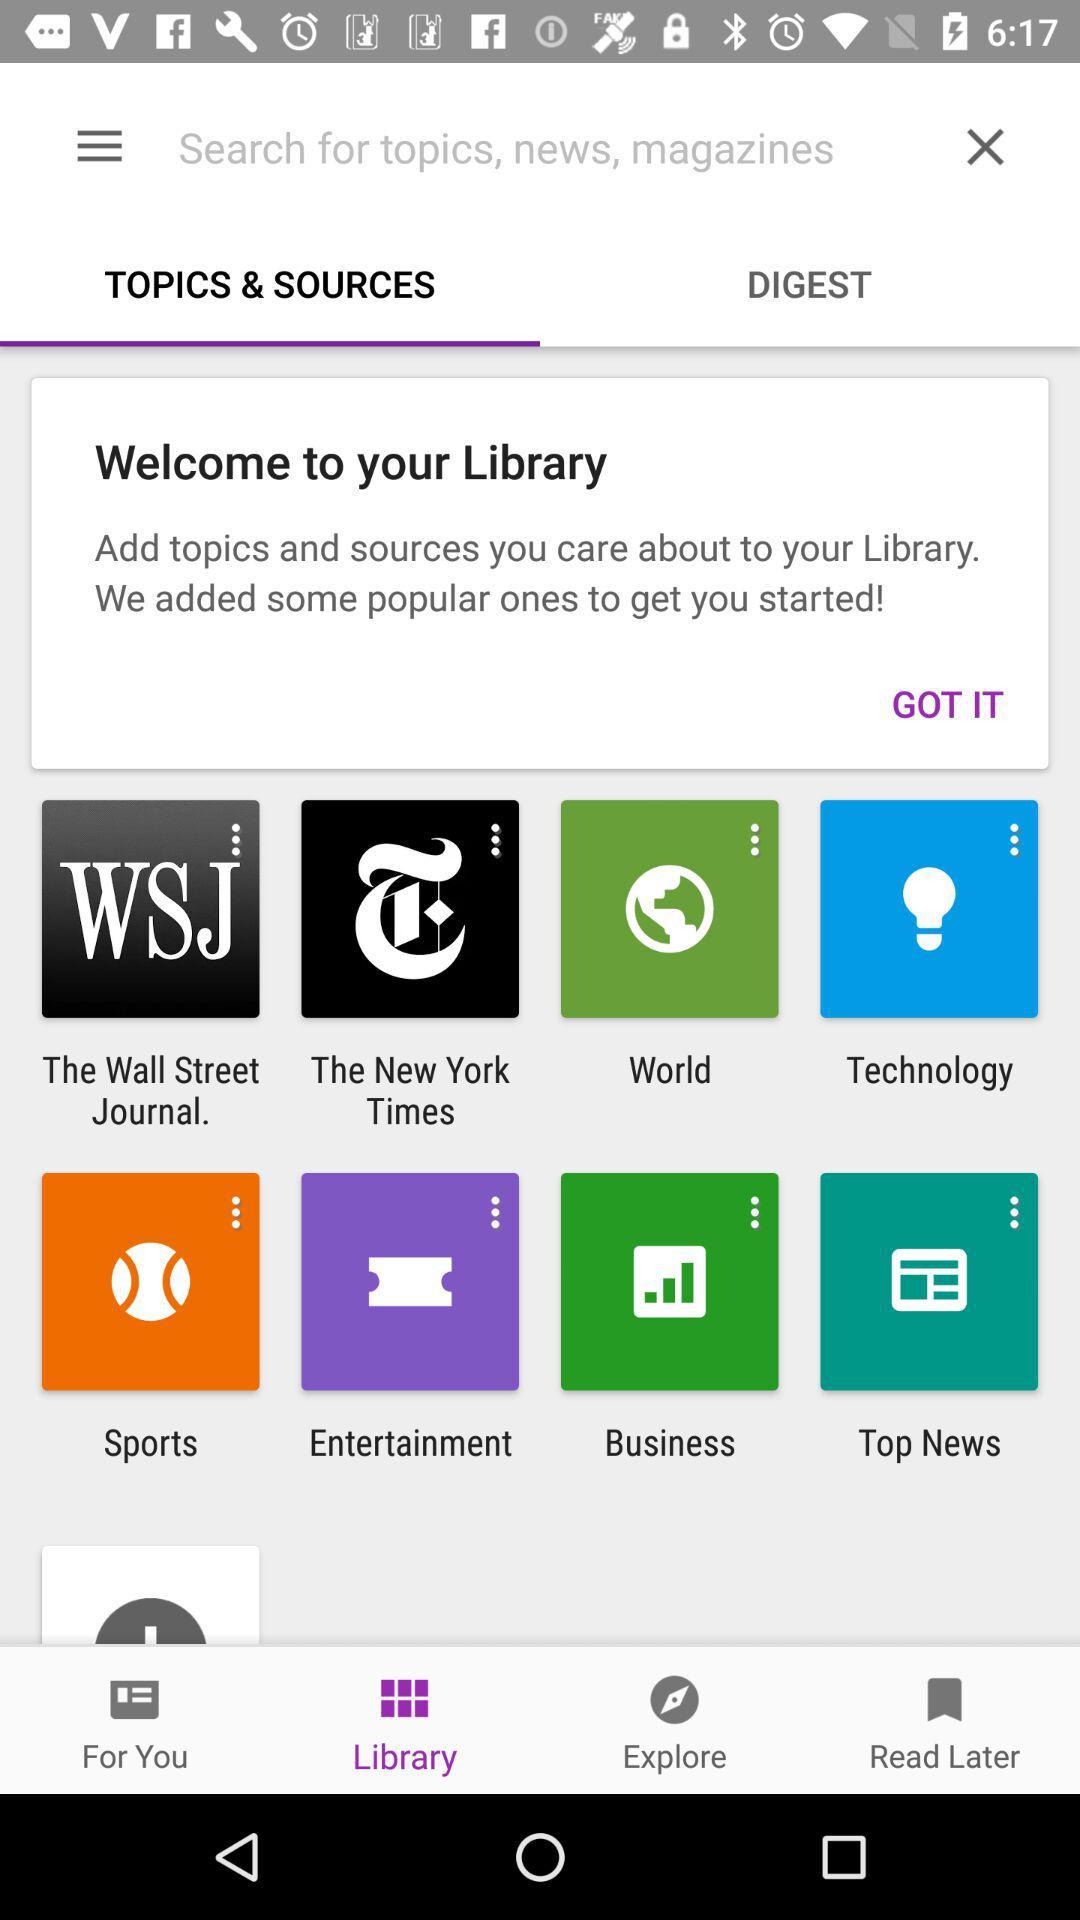Which tab has been selected in the bottom row? The selected tab in the bottom row is "Library". 